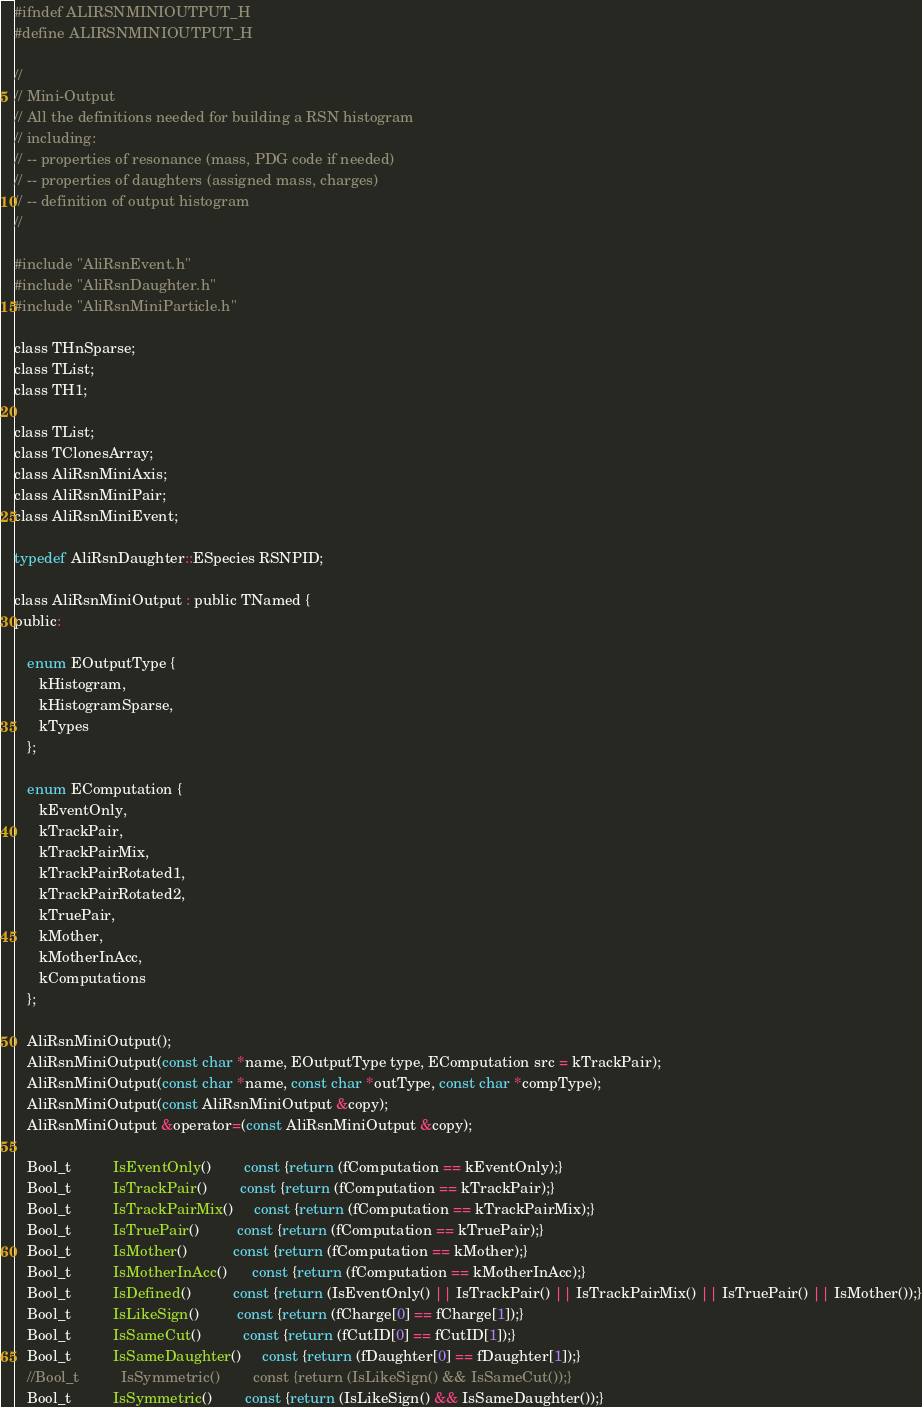<code> <loc_0><loc_0><loc_500><loc_500><_C_>#ifndef ALIRSNMINIOUTPUT_H
#define ALIRSNMINIOUTPUT_H

//
// Mini-Output
// All the definitions needed for building a RSN histogram
// including:
// -- properties of resonance (mass, PDG code if needed)
// -- properties of daughters (assigned mass, charges)
// -- definition of output histogram
//

#include "AliRsnEvent.h"
#include "AliRsnDaughter.h"
#include "AliRsnMiniParticle.h"

class THnSparse;
class TList;
class TH1;

class TList;
class TClonesArray;
class AliRsnMiniAxis;
class AliRsnMiniPair;
class AliRsnMiniEvent;

typedef AliRsnDaughter::ESpecies RSNPID;

class AliRsnMiniOutput : public TNamed {
public:

   enum EOutputType {
      kHistogram,
      kHistogramSparse,
      kTypes
   };

   enum EComputation {
      kEventOnly,
      kTrackPair,
      kTrackPairMix,
      kTrackPairRotated1,
      kTrackPairRotated2,
      kTruePair,
      kMother,
      kMotherInAcc,
      kComputations
   };

   AliRsnMiniOutput();
   AliRsnMiniOutput(const char *name, EOutputType type, EComputation src = kTrackPair);
   AliRsnMiniOutput(const char *name, const char *outType, const char *compType);
   AliRsnMiniOutput(const AliRsnMiniOutput &copy);
   AliRsnMiniOutput &operator=(const AliRsnMiniOutput &copy);

   Bool_t          IsEventOnly()        const {return (fComputation == kEventOnly);}
   Bool_t          IsTrackPair()        const {return (fComputation == kTrackPair);}
   Bool_t          IsTrackPairMix()     const {return (fComputation == kTrackPairMix);}
   Bool_t          IsTruePair()         const {return (fComputation == kTruePair);}
   Bool_t          IsMother()           const {return (fComputation == kMother);}
   Bool_t          IsMotherInAcc()      const {return (fComputation == kMotherInAcc);}
   Bool_t          IsDefined()          const {return (IsEventOnly() || IsTrackPair() || IsTrackPairMix() || IsTruePair() || IsMother());}
   Bool_t          IsLikeSign()         const {return (fCharge[0] == fCharge[1]);}
   Bool_t          IsSameCut()          const {return (fCutID[0] == fCutID[1]);}
   Bool_t          IsSameDaughter()     const {return (fDaughter[0] == fDaughter[1]);}
   //Bool_t          IsSymmetric()        const {return (IsLikeSign() && IsSameCut());}
   Bool_t          IsSymmetric()        const {return (IsLikeSign() && IsSameDaughter());}
</code> 